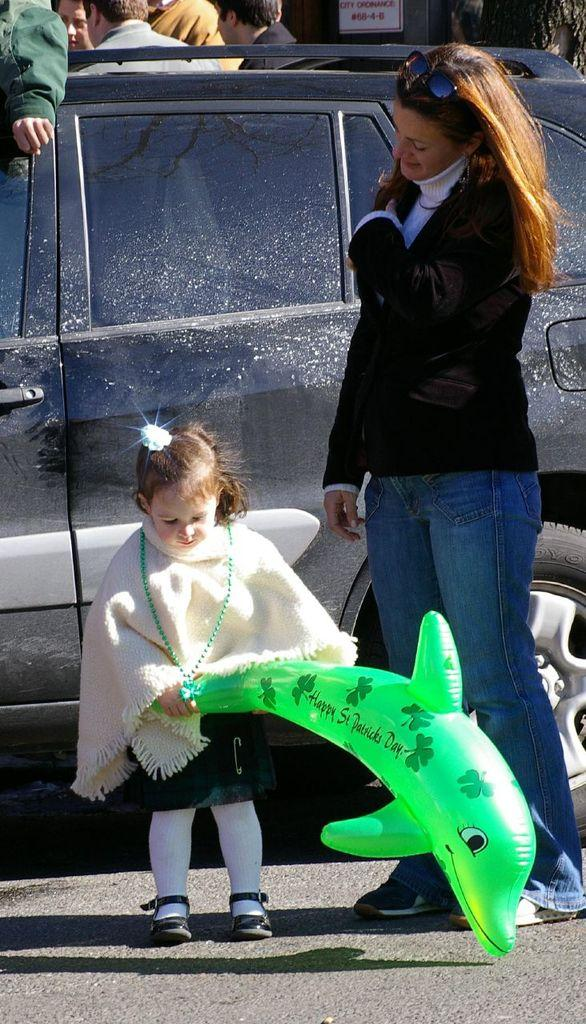Who is present in the image? There is a woman and a kid in the image. What are the woman and the kid doing? The woman and the kid are standing together. What object can be seen in the image besides the people? There is a balloon in the image. What can be seen in the background of the image? There is a car and people visible in the background. What other object is present in the image? There is a board in the image. Can you see any yaks or worms in the image? No, there are no yaks or worms present in the image. What type of field can be seen in the image? There is no field present in the image. 